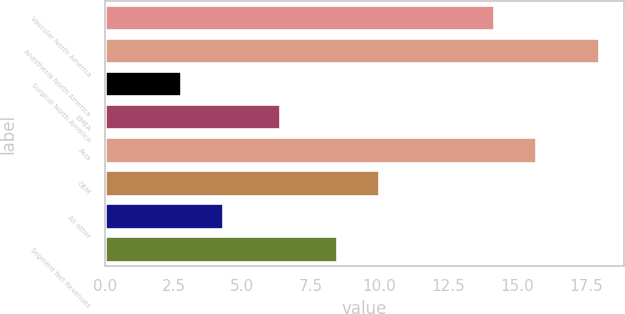Convert chart to OTSL. <chart><loc_0><loc_0><loc_500><loc_500><bar_chart><fcel>Vascular North America<fcel>Anesthesia North America<fcel>Surgical North America<fcel>EMEA<fcel>Asia<fcel>OEM<fcel>All other<fcel>Segment Net Revenues<nl><fcel>14.2<fcel>18<fcel>2.8<fcel>6.4<fcel>15.72<fcel>10.02<fcel>4.32<fcel>8.5<nl></chart> 